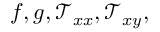<formula> <loc_0><loc_0><loc_500><loc_500>f , g , \mathcal { T } _ { x x } , \mathcal { T } _ { x y } ,</formula> 